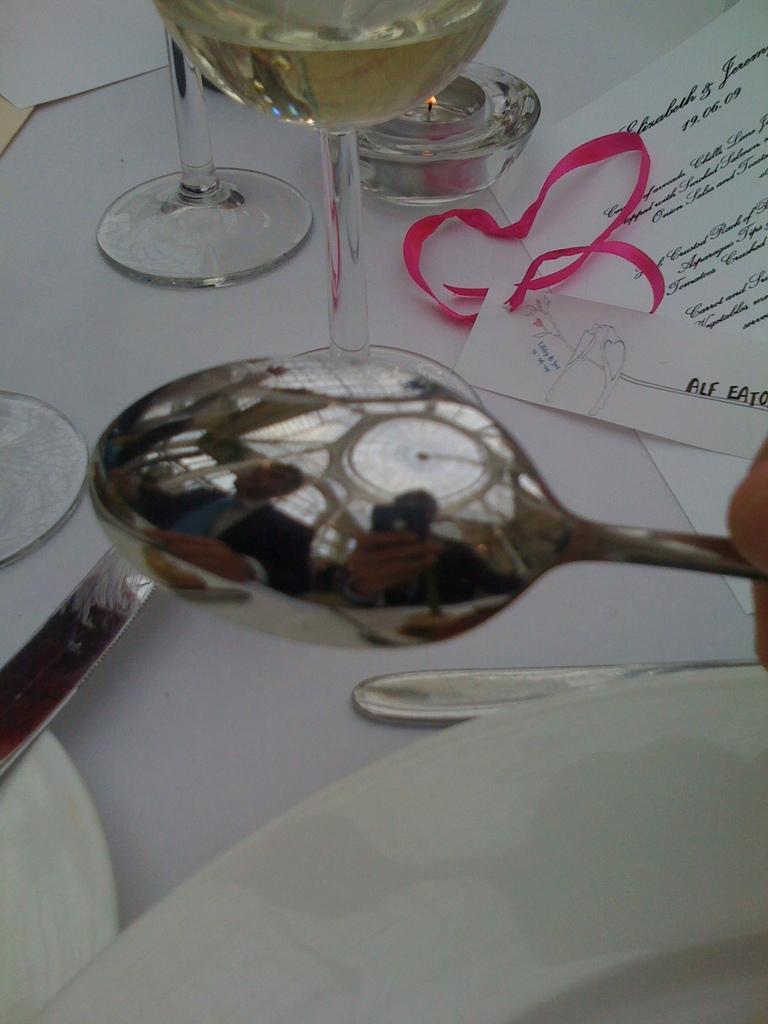In one or two sentences, can you explain what this image depicts? In this image I can see the glasses, spoons and the plates. I can see a piece of paper with some text written on it. 